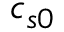<formula> <loc_0><loc_0><loc_500><loc_500>c _ { s 0 }</formula> 